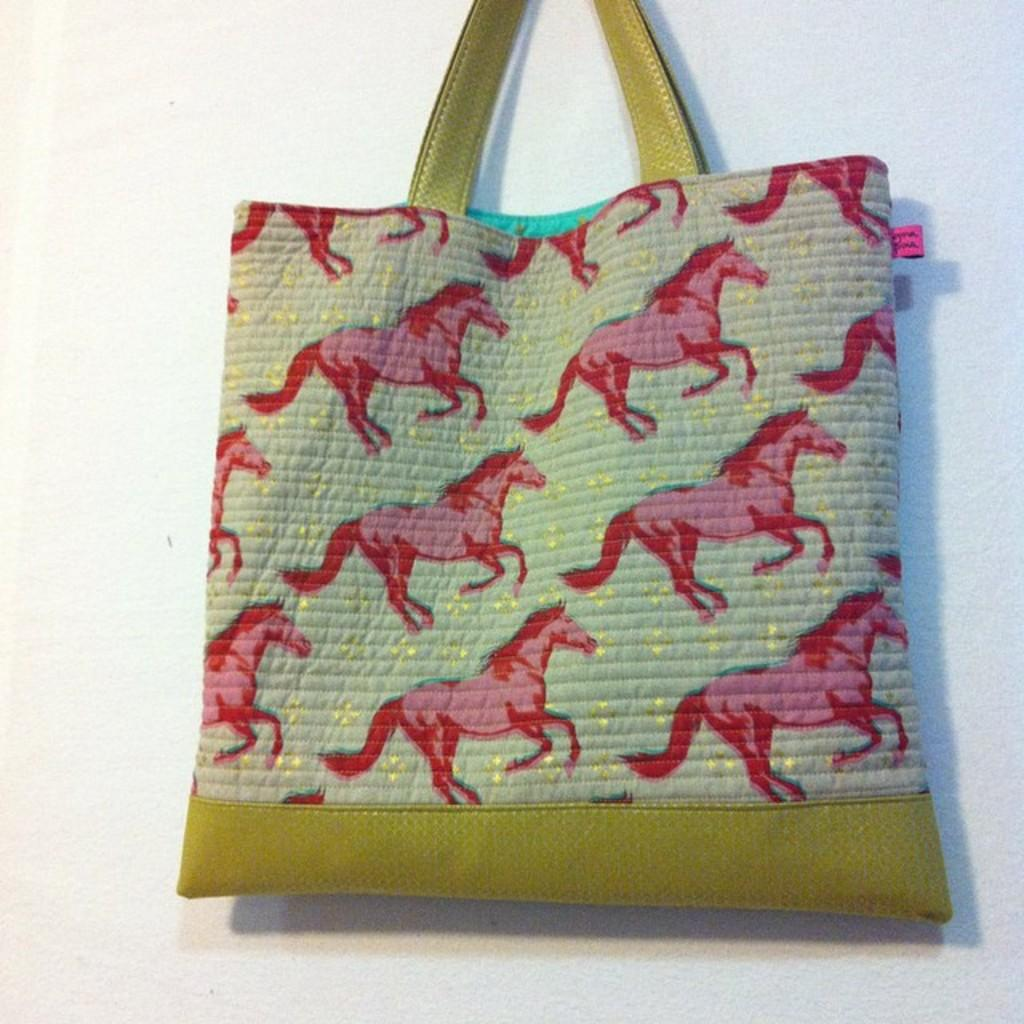What type of images are featured on the handbag in the image? There are horse pictures on the handbag. How many dimes are visible in the image? There are no dimes present in the image. What does the uncle's stomach look like in the image? There is no uncle or reference to a stomach in the image; it only features a handbag with horse pictures. 